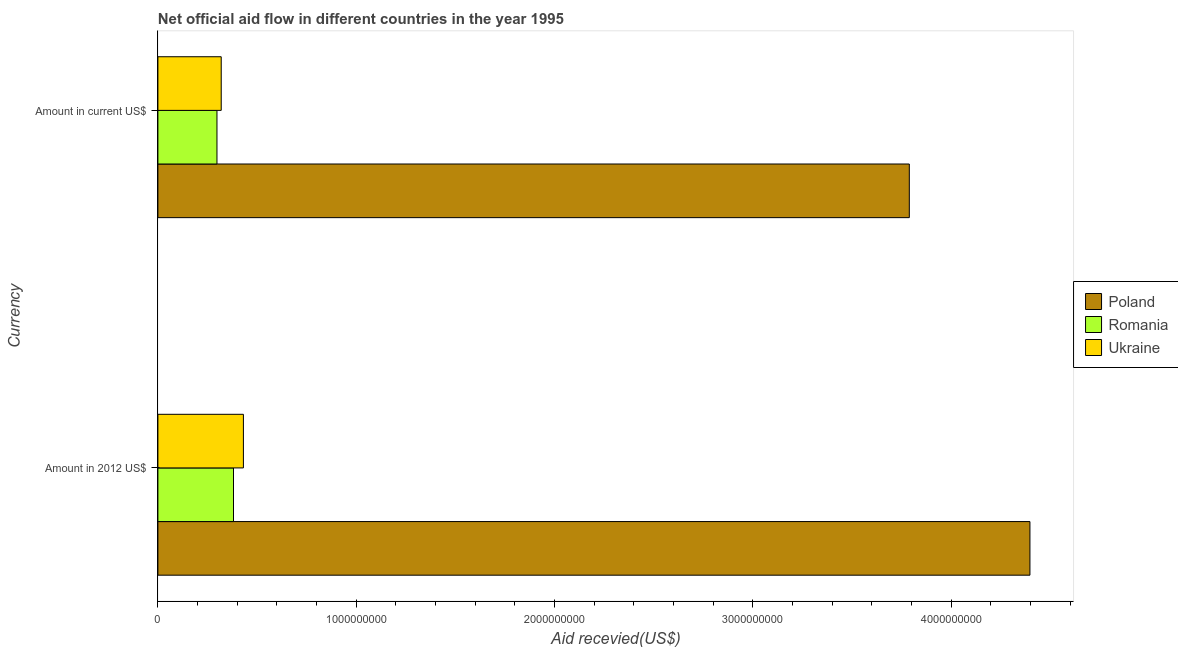How many groups of bars are there?
Give a very brief answer. 2. Are the number of bars per tick equal to the number of legend labels?
Provide a succinct answer. Yes. Are the number of bars on each tick of the Y-axis equal?
Ensure brevity in your answer.  Yes. What is the label of the 2nd group of bars from the top?
Give a very brief answer. Amount in 2012 US$. What is the amount of aid received(expressed in 2012 us$) in Romania?
Give a very brief answer. 3.81e+08. Across all countries, what is the maximum amount of aid received(expressed in us$)?
Provide a succinct answer. 3.79e+09. Across all countries, what is the minimum amount of aid received(expressed in 2012 us$)?
Provide a succinct answer. 3.81e+08. In which country was the amount of aid received(expressed in 2012 us$) maximum?
Keep it short and to the point. Poland. In which country was the amount of aid received(expressed in 2012 us$) minimum?
Your response must be concise. Romania. What is the total amount of aid received(expressed in 2012 us$) in the graph?
Give a very brief answer. 5.21e+09. What is the difference between the amount of aid received(expressed in 2012 us$) in Romania and that in Ukraine?
Your answer should be compact. -5.00e+07. What is the difference between the amount of aid received(expressed in 2012 us$) in Poland and the amount of aid received(expressed in us$) in Ukraine?
Offer a terse response. 4.08e+09. What is the average amount of aid received(expressed in 2012 us$) per country?
Your answer should be very brief. 1.74e+09. What is the difference between the amount of aid received(expressed in 2012 us$) and amount of aid received(expressed in us$) in Poland?
Offer a terse response. 6.08e+08. What is the ratio of the amount of aid received(expressed in us$) in Ukraine to that in Poland?
Provide a short and direct response. 0.08. What does the 3rd bar from the bottom in Amount in 2012 US$ represents?
Provide a short and direct response. Ukraine. How many bars are there?
Your response must be concise. 6. Are all the bars in the graph horizontal?
Keep it short and to the point. Yes. Are the values on the major ticks of X-axis written in scientific E-notation?
Ensure brevity in your answer.  No. Does the graph contain grids?
Give a very brief answer. No. Where does the legend appear in the graph?
Make the answer very short. Center right. How many legend labels are there?
Ensure brevity in your answer.  3. What is the title of the graph?
Your answer should be compact. Net official aid flow in different countries in the year 1995. Does "Least developed countries" appear as one of the legend labels in the graph?
Your answer should be very brief. No. What is the label or title of the X-axis?
Keep it short and to the point. Aid recevied(US$). What is the label or title of the Y-axis?
Offer a very short reply. Currency. What is the Aid recevied(US$) in Poland in Amount in 2012 US$?
Your response must be concise. 4.40e+09. What is the Aid recevied(US$) in Romania in Amount in 2012 US$?
Your answer should be compact. 3.81e+08. What is the Aid recevied(US$) of Ukraine in Amount in 2012 US$?
Give a very brief answer. 4.31e+08. What is the Aid recevied(US$) of Poland in Amount in current US$?
Your answer should be very brief. 3.79e+09. What is the Aid recevied(US$) in Romania in Amount in current US$?
Provide a succinct answer. 2.98e+08. What is the Aid recevied(US$) in Ukraine in Amount in current US$?
Give a very brief answer. 3.19e+08. Across all Currency, what is the maximum Aid recevied(US$) of Poland?
Offer a very short reply. 4.40e+09. Across all Currency, what is the maximum Aid recevied(US$) of Romania?
Ensure brevity in your answer.  3.81e+08. Across all Currency, what is the maximum Aid recevied(US$) of Ukraine?
Offer a very short reply. 4.31e+08. Across all Currency, what is the minimum Aid recevied(US$) of Poland?
Offer a very short reply. 3.79e+09. Across all Currency, what is the minimum Aid recevied(US$) in Romania?
Your response must be concise. 2.98e+08. Across all Currency, what is the minimum Aid recevied(US$) of Ukraine?
Your response must be concise. 3.19e+08. What is the total Aid recevied(US$) of Poland in the graph?
Offer a terse response. 8.19e+09. What is the total Aid recevied(US$) of Romania in the graph?
Offer a very short reply. 6.79e+08. What is the total Aid recevied(US$) in Ukraine in the graph?
Give a very brief answer. 7.50e+08. What is the difference between the Aid recevied(US$) of Poland in Amount in 2012 US$ and that in Amount in current US$?
Provide a succinct answer. 6.08e+08. What is the difference between the Aid recevied(US$) of Romania in Amount in 2012 US$ and that in Amount in current US$?
Offer a terse response. 8.33e+07. What is the difference between the Aid recevied(US$) in Ukraine in Amount in 2012 US$ and that in Amount in current US$?
Offer a very short reply. 1.12e+08. What is the difference between the Aid recevied(US$) in Poland in Amount in 2012 US$ and the Aid recevied(US$) in Romania in Amount in current US$?
Your response must be concise. 4.10e+09. What is the difference between the Aid recevied(US$) in Poland in Amount in 2012 US$ and the Aid recevied(US$) in Ukraine in Amount in current US$?
Make the answer very short. 4.08e+09. What is the difference between the Aid recevied(US$) of Romania in Amount in 2012 US$ and the Aid recevied(US$) of Ukraine in Amount in current US$?
Provide a succinct answer. 6.19e+07. What is the average Aid recevied(US$) in Poland per Currency?
Your response must be concise. 4.09e+09. What is the average Aid recevied(US$) of Romania per Currency?
Your answer should be very brief. 3.40e+08. What is the average Aid recevied(US$) in Ukraine per Currency?
Offer a very short reply. 3.75e+08. What is the difference between the Aid recevied(US$) of Poland and Aid recevied(US$) of Romania in Amount in 2012 US$?
Provide a succinct answer. 4.02e+09. What is the difference between the Aid recevied(US$) of Poland and Aid recevied(US$) of Ukraine in Amount in 2012 US$?
Your response must be concise. 3.97e+09. What is the difference between the Aid recevied(US$) in Romania and Aid recevied(US$) in Ukraine in Amount in 2012 US$?
Your response must be concise. -5.00e+07. What is the difference between the Aid recevied(US$) of Poland and Aid recevied(US$) of Romania in Amount in current US$?
Offer a very short reply. 3.49e+09. What is the difference between the Aid recevied(US$) in Poland and Aid recevied(US$) in Ukraine in Amount in current US$?
Ensure brevity in your answer.  3.47e+09. What is the difference between the Aid recevied(US$) of Romania and Aid recevied(US$) of Ukraine in Amount in current US$?
Your answer should be compact. -2.14e+07. What is the ratio of the Aid recevied(US$) of Poland in Amount in 2012 US$ to that in Amount in current US$?
Offer a terse response. 1.16. What is the ratio of the Aid recevied(US$) of Romania in Amount in 2012 US$ to that in Amount in current US$?
Your answer should be very brief. 1.28. What is the ratio of the Aid recevied(US$) in Ukraine in Amount in 2012 US$ to that in Amount in current US$?
Give a very brief answer. 1.35. What is the difference between the highest and the second highest Aid recevied(US$) in Poland?
Provide a short and direct response. 6.08e+08. What is the difference between the highest and the second highest Aid recevied(US$) of Romania?
Make the answer very short. 8.33e+07. What is the difference between the highest and the second highest Aid recevied(US$) in Ukraine?
Offer a terse response. 1.12e+08. What is the difference between the highest and the lowest Aid recevied(US$) in Poland?
Offer a very short reply. 6.08e+08. What is the difference between the highest and the lowest Aid recevied(US$) of Romania?
Your response must be concise. 8.33e+07. What is the difference between the highest and the lowest Aid recevied(US$) in Ukraine?
Keep it short and to the point. 1.12e+08. 